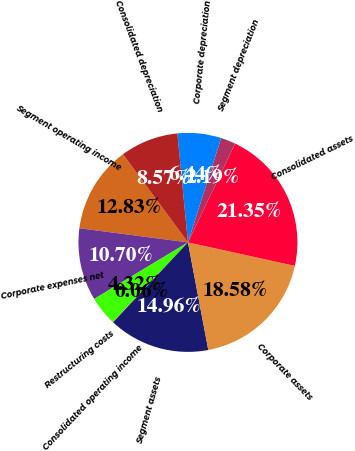<chart> <loc_0><loc_0><loc_500><loc_500><pie_chart><fcel>Segment operating income<fcel>Corporate expenses net<fcel>Restructuring costs<fcel>Consolidated operating income<fcel>Segment assets<fcel>Corporate assets<fcel>Consolidated assets<fcel>Segment depreciation<fcel>Corporate depreciation<fcel>Consolidated depreciation<nl><fcel>12.83%<fcel>10.7%<fcel>4.32%<fcel>0.06%<fcel>14.96%<fcel>18.58%<fcel>21.35%<fcel>2.19%<fcel>6.44%<fcel>8.57%<nl></chart> 